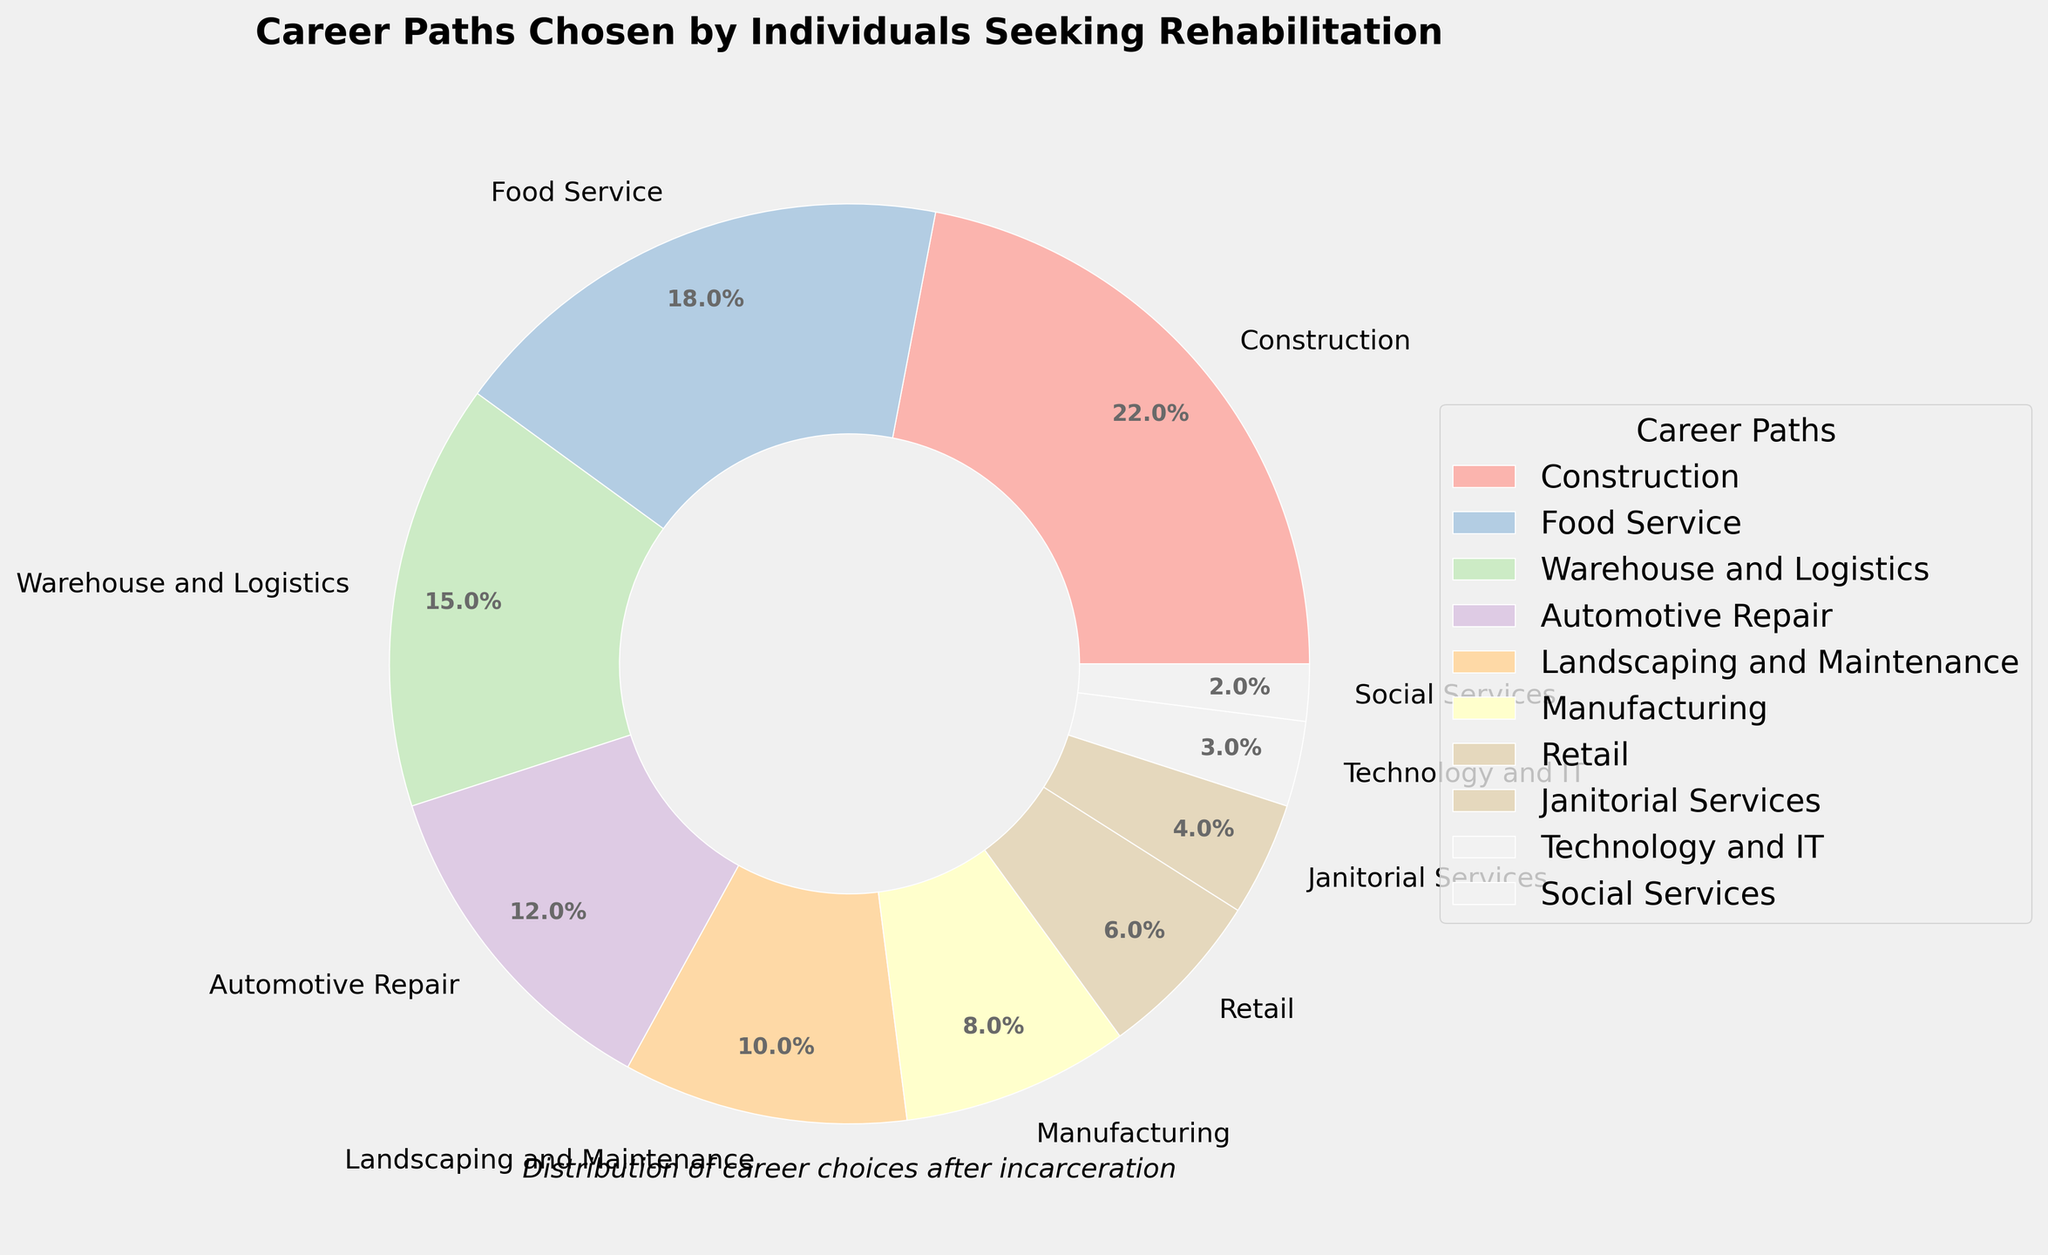Which career path has the highest percentage? The largest percentage shown in the pie chart is 22%, which corresponds to Construction. This indicates that the most popular career path chosen is Construction.
Answer: Construction What is the combined percentage of individuals working in Automotive Repair and Manufacturing? The pie chart shows Automotive Repair at 12% and Manufacturing at 8%. Adding these percentages together gives 12% + 8% = 20%.
Answer: 20% How does the percentage for Technology and IT compare with that for Retail? Technology and IT has a percentage of 3%, while Retail has a percentage of 6%. Since 3% is less than 6%, Technology and IT has a lower percentage compared to Retail.
Answer: Technology and IT is lower Which career path has the smallest percentage? The smallest percentage shown in the pie chart is 2%, which corresponds to Social Services. This indicates that the least popular career path chosen is Social Services.
Answer: Social Services How many career paths have a percentage of 10% or higher? The career paths with percentages of 10% or higher are Construction (22%), Food Service (18%), Warehouse and Logistics (15%), and Automotive Repair (12%), and Landscaping and Maintenance (10%). Counting these, there are 5 such career paths.
Answer: 5 What is the difference in percentage between Food Service and Janitorial Services? The pie chart shows Food Service at 18% and Janitorial Services at 4%. Subtracting these percentages gives 18% - 4% = 14%.
Answer: 14% What is the combined percentage of the three least chosen career paths? The three least chosen career paths are Technology and IT (3%), Social Services (2%), and Janitorial Services (4%). Adding these percentages together gives 3% + 2% + 4% = 9%.
Answer: 9% Which two career paths have a cumulative percentage closest to 30%? The career paths closest to a cumulative 30% can be checked by adding subsets. Construction (22%) and Retail (6%) sum up to 28%, which looks to be closest.
Answer: Construction and Retail What is the visual attribute that makes it easy to distinguish the wedges in the pie chart? The wedges differ in their colors, which are created using a pastel color palette. Additionally, each wedge is labeled with both the career path and percentage, making it easy to distinguish and interpret the data visually.
Answer: Colors and labels 